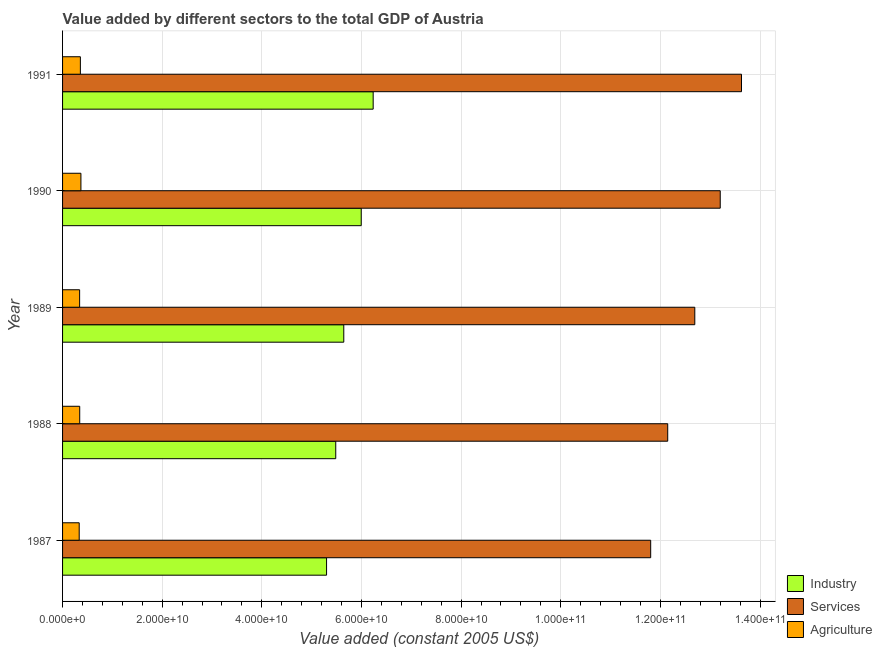How many different coloured bars are there?
Ensure brevity in your answer.  3. Are the number of bars per tick equal to the number of legend labels?
Offer a terse response. Yes. Are the number of bars on each tick of the Y-axis equal?
Your answer should be compact. Yes. How many bars are there on the 3rd tick from the top?
Provide a succinct answer. 3. How many bars are there on the 5th tick from the bottom?
Give a very brief answer. 3. What is the label of the 1st group of bars from the top?
Provide a short and direct response. 1991. What is the value added by industrial sector in 1991?
Your response must be concise. 6.23e+1. Across all years, what is the maximum value added by agricultural sector?
Ensure brevity in your answer.  3.69e+09. Across all years, what is the minimum value added by services?
Your answer should be compact. 1.18e+11. In which year was the value added by agricultural sector minimum?
Offer a terse response. 1987. What is the total value added by services in the graph?
Provide a succinct answer. 6.35e+11. What is the difference between the value added by agricultural sector in 1987 and that in 1991?
Your response must be concise. -2.36e+08. What is the difference between the value added by industrial sector in 1991 and the value added by agricultural sector in 1988?
Offer a terse response. 5.89e+1. What is the average value added by services per year?
Provide a succinct answer. 1.27e+11. In the year 1989, what is the difference between the value added by services and value added by industrial sector?
Provide a succinct answer. 7.05e+1. Is the value added by services in 1987 less than that in 1991?
Provide a succinct answer. Yes. Is the difference between the value added by services in 1990 and 1991 greater than the difference between the value added by agricultural sector in 1990 and 1991?
Provide a short and direct response. No. What is the difference between the highest and the second highest value added by industrial sector?
Your response must be concise. 2.40e+09. What is the difference between the highest and the lowest value added by services?
Ensure brevity in your answer.  1.82e+1. Is the sum of the value added by agricultural sector in 1988 and 1991 greater than the maximum value added by industrial sector across all years?
Your answer should be very brief. No. What does the 1st bar from the top in 1991 represents?
Keep it short and to the point. Agriculture. What does the 3rd bar from the bottom in 1991 represents?
Offer a terse response. Agriculture. Is it the case that in every year, the sum of the value added by industrial sector and value added by services is greater than the value added by agricultural sector?
Provide a succinct answer. Yes. How many bars are there?
Your response must be concise. 15. Are all the bars in the graph horizontal?
Keep it short and to the point. Yes. Does the graph contain any zero values?
Offer a very short reply. No. Where does the legend appear in the graph?
Provide a succinct answer. Bottom right. How many legend labels are there?
Give a very brief answer. 3. What is the title of the graph?
Your response must be concise. Value added by different sectors to the total GDP of Austria. What is the label or title of the X-axis?
Your answer should be compact. Value added (constant 2005 US$). What is the label or title of the Y-axis?
Keep it short and to the point. Year. What is the Value added (constant 2005 US$) in Industry in 1987?
Offer a terse response. 5.30e+1. What is the Value added (constant 2005 US$) of Services in 1987?
Provide a short and direct response. 1.18e+11. What is the Value added (constant 2005 US$) of Agriculture in 1987?
Keep it short and to the point. 3.34e+09. What is the Value added (constant 2005 US$) in Industry in 1988?
Keep it short and to the point. 5.48e+1. What is the Value added (constant 2005 US$) in Services in 1988?
Offer a very short reply. 1.21e+11. What is the Value added (constant 2005 US$) in Agriculture in 1988?
Provide a short and direct response. 3.44e+09. What is the Value added (constant 2005 US$) of Industry in 1989?
Offer a terse response. 5.64e+1. What is the Value added (constant 2005 US$) in Services in 1989?
Give a very brief answer. 1.27e+11. What is the Value added (constant 2005 US$) in Agriculture in 1989?
Your answer should be compact. 3.42e+09. What is the Value added (constant 2005 US$) of Industry in 1990?
Give a very brief answer. 6.00e+1. What is the Value added (constant 2005 US$) in Services in 1990?
Keep it short and to the point. 1.32e+11. What is the Value added (constant 2005 US$) in Agriculture in 1990?
Offer a terse response. 3.69e+09. What is the Value added (constant 2005 US$) in Industry in 1991?
Keep it short and to the point. 6.23e+1. What is the Value added (constant 2005 US$) of Services in 1991?
Offer a very short reply. 1.36e+11. What is the Value added (constant 2005 US$) of Agriculture in 1991?
Give a very brief answer. 3.58e+09. Across all years, what is the maximum Value added (constant 2005 US$) in Industry?
Provide a succinct answer. 6.23e+1. Across all years, what is the maximum Value added (constant 2005 US$) in Services?
Make the answer very short. 1.36e+11. Across all years, what is the maximum Value added (constant 2005 US$) of Agriculture?
Your response must be concise. 3.69e+09. Across all years, what is the minimum Value added (constant 2005 US$) of Industry?
Ensure brevity in your answer.  5.30e+1. Across all years, what is the minimum Value added (constant 2005 US$) in Services?
Offer a terse response. 1.18e+11. Across all years, what is the minimum Value added (constant 2005 US$) of Agriculture?
Ensure brevity in your answer.  3.34e+09. What is the total Value added (constant 2005 US$) in Industry in the graph?
Your answer should be compact. 2.87e+11. What is the total Value added (constant 2005 US$) of Services in the graph?
Offer a terse response. 6.35e+11. What is the total Value added (constant 2005 US$) of Agriculture in the graph?
Make the answer very short. 1.75e+1. What is the difference between the Value added (constant 2005 US$) in Industry in 1987 and that in 1988?
Provide a succinct answer. -1.84e+09. What is the difference between the Value added (constant 2005 US$) in Services in 1987 and that in 1988?
Your answer should be very brief. -3.42e+09. What is the difference between the Value added (constant 2005 US$) in Agriculture in 1987 and that in 1988?
Offer a very short reply. -1.02e+08. What is the difference between the Value added (constant 2005 US$) of Industry in 1987 and that in 1989?
Your answer should be compact. -3.46e+09. What is the difference between the Value added (constant 2005 US$) of Services in 1987 and that in 1989?
Your answer should be compact. -8.85e+09. What is the difference between the Value added (constant 2005 US$) in Agriculture in 1987 and that in 1989?
Give a very brief answer. -8.47e+07. What is the difference between the Value added (constant 2005 US$) of Industry in 1987 and that in 1990?
Ensure brevity in your answer.  -6.96e+09. What is the difference between the Value added (constant 2005 US$) of Services in 1987 and that in 1990?
Offer a very short reply. -1.40e+1. What is the difference between the Value added (constant 2005 US$) of Agriculture in 1987 and that in 1990?
Your response must be concise. -3.46e+08. What is the difference between the Value added (constant 2005 US$) in Industry in 1987 and that in 1991?
Provide a short and direct response. -9.36e+09. What is the difference between the Value added (constant 2005 US$) in Services in 1987 and that in 1991?
Make the answer very short. -1.82e+1. What is the difference between the Value added (constant 2005 US$) of Agriculture in 1987 and that in 1991?
Make the answer very short. -2.36e+08. What is the difference between the Value added (constant 2005 US$) of Industry in 1988 and that in 1989?
Give a very brief answer. -1.61e+09. What is the difference between the Value added (constant 2005 US$) of Services in 1988 and that in 1989?
Provide a short and direct response. -5.44e+09. What is the difference between the Value added (constant 2005 US$) in Agriculture in 1988 and that in 1989?
Offer a terse response. 1.73e+07. What is the difference between the Value added (constant 2005 US$) of Industry in 1988 and that in 1990?
Make the answer very short. -5.12e+09. What is the difference between the Value added (constant 2005 US$) of Services in 1988 and that in 1990?
Ensure brevity in your answer.  -1.05e+1. What is the difference between the Value added (constant 2005 US$) in Agriculture in 1988 and that in 1990?
Provide a short and direct response. -2.44e+08. What is the difference between the Value added (constant 2005 US$) in Industry in 1988 and that in 1991?
Give a very brief answer. -7.51e+09. What is the difference between the Value added (constant 2005 US$) of Services in 1988 and that in 1991?
Your answer should be very brief. -1.48e+1. What is the difference between the Value added (constant 2005 US$) of Agriculture in 1988 and that in 1991?
Offer a terse response. -1.34e+08. What is the difference between the Value added (constant 2005 US$) in Industry in 1989 and that in 1990?
Keep it short and to the point. -3.50e+09. What is the difference between the Value added (constant 2005 US$) in Services in 1989 and that in 1990?
Provide a short and direct response. -5.10e+09. What is the difference between the Value added (constant 2005 US$) in Agriculture in 1989 and that in 1990?
Provide a succinct answer. -2.61e+08. What is the difference between the Value added (constant 2005 US$) of Industry in 1989 and that in 1991?
Provide a short and direct response. -5.90e+09. What is the difference between the Value added (constant 2005 US$) of Services in 1989 and that in 1991?
Offer a very short reply. -9.37e+09. What is the difference between the Value added (constant 2005 US$) of Agriculture in 1989 and that in 1991?
Your answer should be compact. -1.51e+08. What is the difference between the Value added (constant 2005 US$) of Industry in 1990 and that in 1991?
Ensure brevity in your answer.  -2.40e+09. What is the difference between the Value added (constant 2005 US$) in Services in 1990 and that in 1991?
Give a very brief answer. -4.27e+09. What is the difference between the Value added (constant 2005 US$) in Agriculture in 1990 and that in 1991?
Ensure brevity in your answer.  1.10e+08. What is the difference between the Value added (constant 2005 US$) of Industry in 1987 and the Value added (constant 2005 US$) of Services in 1988?
Your answer should be compact. -6.85e+1. What is the difference between the Value added (constant 2005 US$) of Industry in 1987 and the Value added (constant 2005 US$) of Agriculture in 1988?
Provide a succinct answer. 4.95e+1. What is the difference between the Value added (constant 2005 US$) in Services in 1987 and the Value added (constant 2005 US$) in Agriculture in 1988?
Make the answer very short. 1.15e+11. What is the difference between the Value added (constant 2005 US$) in Industry in 1987 and the Value added (constant 2005 US$) in Services in 1989?
Your answer should be very brief. -7.39e+1. What is the difference between the Value added (constant 2005 US$) of Industry in 1987 and the Value added (constant 2005 US$) of Agriculture in 1989?
Make the answer very short. 4.96e+1. What is the difference between the Value added (constant 2005 US$) in Services in 1987 and the Value added (constant 2005 US$) in Agriculture in 1989?
Make the answer very short. 1.15e+11. What is the difference between the Value added (constant 2005 US$) of Industry in 1987 and the Value added (constant 2005 US$) of Services in 1990?
Provide a short and direct response. -7.90e+1. What is the difference between the Value added (constant 2005 US$) in Industry in 1987 and the Value added (constant 2005 US$) in Agriculture in 1990?
Ensure brevity in your answer.  4.93e+1. What is the difference between the Value added (constant 2005 US$) in Services in 1987 and the Value added (constant 2005 US$) in Agriculture in 1990?
Your response must be concise. 1.14e+11. What is the difference between the Value added (constant 2005 US$) of Industry in 1987 and the Value added (constant 2005 US$) of Services in 1991?
Make the answer very short. -8.33e+1. What is the difference between the Value added (constant 2005 US$) of Industry in 1987 and the Value added (constant 2005 US$) of Agriculture in 1991?
Your response must be concise. 4.94e+1. What is the difference between the Value added (constant 2005 US$) of Services in 1987 and the Value added (constant 2005 US$) of Agriculture in 1991?
Your answer should be compact. 1.14e+11. What is the difference between the Value added (constant 2005 US$) in Industry in 1988 and the Value added (constant 2005 US$) in Services in 1989?
Offer a very short reply. -7.21e+1. What is the difference between the Value added (constant 2005 US$) of Industry in 1988 and the Value added (constant 2005 US$) of Agriculture in 1989?
Offer a very short reply. 5.14e+1. What is the difference between the Value added (constant 2005 US$) of Services in 1988 and the Value added (constant 2005 US$) of Agriculture in 1989?
Provide a succinct answer. 1.18e+11. What is the difference between the Value added (constant 2005 US$) in Industry in 1988 and the Value added (constant 2005 US$) in Services in 1990?
Your answer should be very brief. -7.72e+1. What is the difference between the Value added (constant 2005 US$) of Industry in 1988 and the Value added (constant 2005 US$) of Agriculture in 1990?
Your answer should be compact. 5.12e+1. What is the difference between the Value added (constant 2005 US$) in Services in 1988 and the Value added (constant 2005 US$) in Agriculture in 1990?
Your answer should be very brief. 1.18e+11. What is the difference between the Value added (constant 2005 US$) of Industry in 1988 and the Value added (constant 2005 US$) of Services in 1991?
Provide a succinct answer. -8.14e+1. What is the difference between the Value added (constant 2005 US$) in Industry in 1988 and the Value added (constant 2005 US$) in Agriculture in 1991?
Keep it short and to the point. 5.13e+1. What is the difference between the Value added (constant 2005 US$) of Services in 1988 and the Value added (constant 2005 US$) of Agriculture in 1991?
Your answer should be compact. 1.18e+11. What is the difference between the Value added (constant 2005 US$) of Industry in 1989 and the Value added (constant 2005 US$) of Services in 1990?
Provide a succinct answer. -7.56e+1. What is the difference between the Value added (constant 2005 US$) in Industry in 1989 and the Value added (constant 2005 US$) in Agriculture in 1990?
Provide a succinct answer. 5.28e+1. What is the difference between the Value added (constant 2005 US$) in Services in 1989 and the Value added (constant 2005 US$) in Agriculture in 1990?
Give a very brief answer. 1.23e+11. What is the difference between the Value added (constant 2005 US$) of Industry in 1989 and the Value added (constant 2005 US$) of Services in 1991?
Provide a succinct answer. -7.98e+1. What is the difference between the Value added (constant 2005 US$) of Industry in 1989 and the Value added (constant 2005 US$) of Agriculture in 1991?
Ensure brevity in your answer.  5.29e+1. What is the difference between the Value added (constant 2005 US$) of Services in 1989 and the Value added (constant 2005 US$) of Agriculture in 1991?
Your response must be concise. 1.23e+11. What is the difference between the Value added (constant 2005 US$) of Industry in 1990 and the Value added (constant 2005 US$) of Services in 1991?
Ensure brevity in your answer.  -7.63e+1. What is the difference between the Value added (constant 2005 US$) in Industry in 1990 and the Value added (constant 2005 US$) in Agriculture in 1991?
Keep it short and to the point. 5.64e+1. What is the difference between the Value added (constant 2005 US$) in Services in 1990 and the Value added (constant 2005 US$) in Agriculture in 1991?
Provide a succinct answer. 1.28e+11. What is the average Value added (constant 2005 US$) of Industry per year?
Offer a terse response. 5.73e+1. What is the average Value added (constant 2005 US$) of Services per year?
Provide a succinct answer. 1.27e+11. What is the average Value added (constant 2005 US$) of Agriculture per year?
Provide a short and direct response. 3.49e+09. In the year 1987, what is the difference between the Value added (constant 2005 US$) in Industry and Value added (constant 2005 US$) in Services?
Your answer should be very brief. -6.51e+1. In the year 1987, what is the difference between the Value added (constant 2005 US$) of Industry and Value added (constant 2005 US$) of Agriculture?
Offer a very short reply. 4.97e+1. In the year 1987, what is the difference between the Value added (constant 2005 US$) in Services and Value added (constant 2005 US$) in Agriculture?
Your answer should be compact. 1.15e+11. In the year 1988, what is the difference between the Value added (constant 2005 US$) of Industry and Value added (constant 2005 US$) of Services?
Ensure brevity in your answer.  -6.66e+1. In the year 1988, what is the difference between the Value added (constant 2005 US$) in Industry and Value added (constant 2005 US$) in Agriculture?
Offer a terse response. 5.14e+1. In the year 1988, what is the difference between the Value added (constant 2005 US$) in Services and Value added (constant 2005 US$) in Agriculture?
Make the answer very short. 1.18e+11. In the year 1989, what is the difference between the Value added (constant 2005 US$) of Industry and Value added (constant 2005 US$) of Services?
Make the answer very short. -7.05e+1. In the year 1989, what is the difference between the Value added (constant 2005 US$) in Industry and Value added (constant 2005 US$) in Agriculture?
Offer a terse response. 5.30e+1. In the year 1989, what is the difference between the Value added (constant 2005 US$) of Services and Value added (constant 2005 US$) of Agriculture?
Provide a short and direct response. 1.23e+11. In the year 1990, what is the difference between the Value added (constant 2005 US$) in Industry and Value added (constant 2005 US$) in Services?
Provide a short and direct response. -7.21e+1. In the year 1990, what is the difference between the Value added (constant 2005 US$) of Industry and Value added (constant 2005 US$) of Agriculture?
Your response must be concise. 5.63e+1. In the year 1990, what is the difference between the Value added (constant 2005 US$) in Services and Value added (constant 2005 US$) in Agriculture?
Offer a terse response. 1.28e+11. In the year 1991, what is the difference between the Value added (constant 2005 US$) of Industry and Value added (constant 2005 US$) of Services?
Your answer should be very brief. -7.39e+1. In the year 1991, what is the difference between the Value added (constant 2005 US$) of Industry and Value added (constant 2005 US$) of Agriculture?
Provide a short and direct response. 5.88e+1. In the year 1991, what is the difference between the Value added (constant 2005 US$) of Services and Value added (constant 2005 US$) of Agriculture?
Offer a very short reply. 1.33e+11. What is the ratio of the Value added (constant 2005 US$) in Industry in 1987 to that in 1988?
Your answer should be very brief. 0.97. What is the ratio of the Value added (constant 2005 US$) in Services in 1987 to that in 1988?
Keep it short and to the point. 0.97. What is the ratio of the Value added (constant 2005 US$) in Agriculture in 1987 to that in 1988?
Provide a short and direct response. 0.97. What is the ratio of the Value added (constant 2005 US$) in Industry in 1987 to that in 1989?
Provide a succinct answer. 0.94. What is the ratio of the Value added (constant 2005 US$) of Services in 1987 to that in 1989?
Offer a terse response. 0.93. What is the ratio of the Value added (constant 2005 US$) of Agriculture in 1987 to that in 1989?
Your answer should be compact. 0.98. What is the ratio of the Value added (constant 2005 US$) in Industry in 1987 to that in 1990?
Give a very brief answer. 0.88. What is the ratio of the Value added (constant 2005 US$) in Services in 1987 to that in 1990?
Ensure brevity in your answer.  0.89. What is the ratio of the Value added (constant 2005 US$) in Agriculture in 1987 to that in 1990?
Offer a terse response. 0.91. What is the ratio of the Value added (constant 2005 US$) in Industry in 1987 to that in 1991?
Your answer should be very brief. 0.85. What is the ratio of the Value added (constant 2005 US$) of Services in 1987 to that in 1991?
Your answer should be compact. 0.87. What is the ratio of the Value added (constant 2005 US$) of Agriculture in 1987 to that in 1991?
Offer a very short reply. 0.93. What is the ratio of the Value added (constant 2005 US$) of Industry in 1988 to that in 1989?
Ensure brevity in your answer.  0.97. What is the ratio of the Value added (constant 2005 US$) of Services in 1988 to that in 1989?
Give a very brief answer. 0.96. What is the ratio of the Value added (constant 2005 US$) of Agriculture in 1988 to that in 1989?
Provide a succinct answer. 1. What is the ratio of the Value added (constant 2005 US$) of Industry in 1988 to that in 1990?
Give a very brief answer. 0.91. What is the ratio of the Value added (constant 2005 US$) in Services in 1988 to that in 1990?
Provide a succinct answer. 0.92. What is the ratio of the Value added (constant 2005 US$) in Agriculture in 1988 to that in 1990?
Your answer should be very brief. 0.93. What is the ratio of the Value added (constant 2005 US$) of Industry in 1988 to that in 1991?
Your answer should be very brief. 0.88. What is the ratio of the Value added (constant 2005 US$) in Services in 1988 to that in 1991?
Provide a succinct answer. 0.89. What is the ratio of the Value added (constant 2005 US$) in Agriculture in 1988 to that in 1991?
Provide a short and direct response. 0.96. What is the ratio of the Value added (constant 2005 US$) of Industry in 1989 to that in 1990?
Your answer should be compact. 0.94. What is the ratio of the Value added (constant 2005 US$) in Services in 1989 to that in 1990?
Your answer should be very brief. 0.96. What is the ratio of the Value added (constant 2005 US$) in Agriculture in 1989 to that in 1990?
Give a very brief answer. 0.93. What is the ratio of the Value added (constant 2005 US$) in Industry in 1989 to that in 1991?
Provide a short and direct response. 0.91. What is the ratio of the Value added (constant 2005 US$) in Services in 1989 to that in 1991?
Offer a terse response. 0.93. What is the ratio of the Value added (constant 2005 US$) of Agriculture in 1989 to that in 1991?
Ensure brevity in your answer.  0.96. What is the ratio of the Value added (constant 2005 US$) in Industry in 1990 to that in 1991?
Offer a very short reply. 0.96. What is the ratio of the Value added (constant 2005 US$) of Services in 1990 to that in 1991?
Offer a very short reply. 0.97. What is the ratio of the Value added (constant 2005 US$) in Agriculture in 1990 to that in 1991?
Offer a very short reply. 1.03. What is the difference between the highest and the second highest Value added (constant 2005 US$) of Industry?
Give a very brief answer. 2.40e+09. What is the difference between the highest and the second highest Value added (constant 2005 US$) in Services?
Make the answer very short. 4.27e+09. What is the difference between the highest and the second highest Value added (constant 2005 US$) in Agriculture?
Offer a very short reply. 1.10e+08. What is the difference between the highest and the lowest Value added (constant 2005 US$) of Industry?
Offer a terse response. 9.36e+09. What is the difference between the highest and the lowest Value added (constant 2005 US$) of Services?
Your response must be concise. 1.82e+1. What is the difference between the highest and the lowest Value added (constant 2005 US$) of Agriculture?
Make the answer very short. 3.46e+08. 